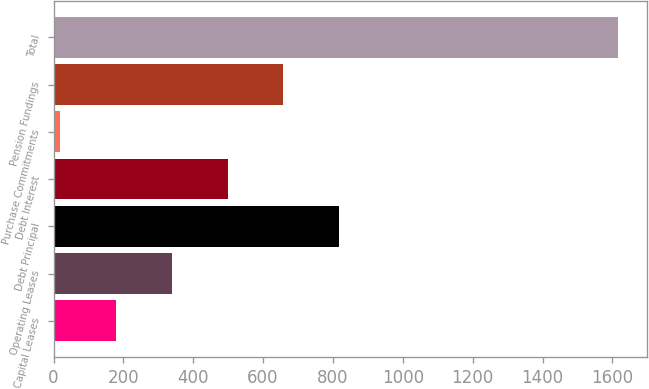Convert chart. <chart><loc_0><loc_0><loc_500><loc_500><bar_chart><fcel>Capital Leases<fcel>Operating Leases<fcel>Debt Principal<fcel>Debt Interest<fcel>Purchase Commitments<fcel>Pension Fundings<fcel>Total<nl><fcel>178.8<fcel>338.6<fcel>818<fcel>498.4<fcel>19<fcel>658.2<fcel>1617<nl></chart> 